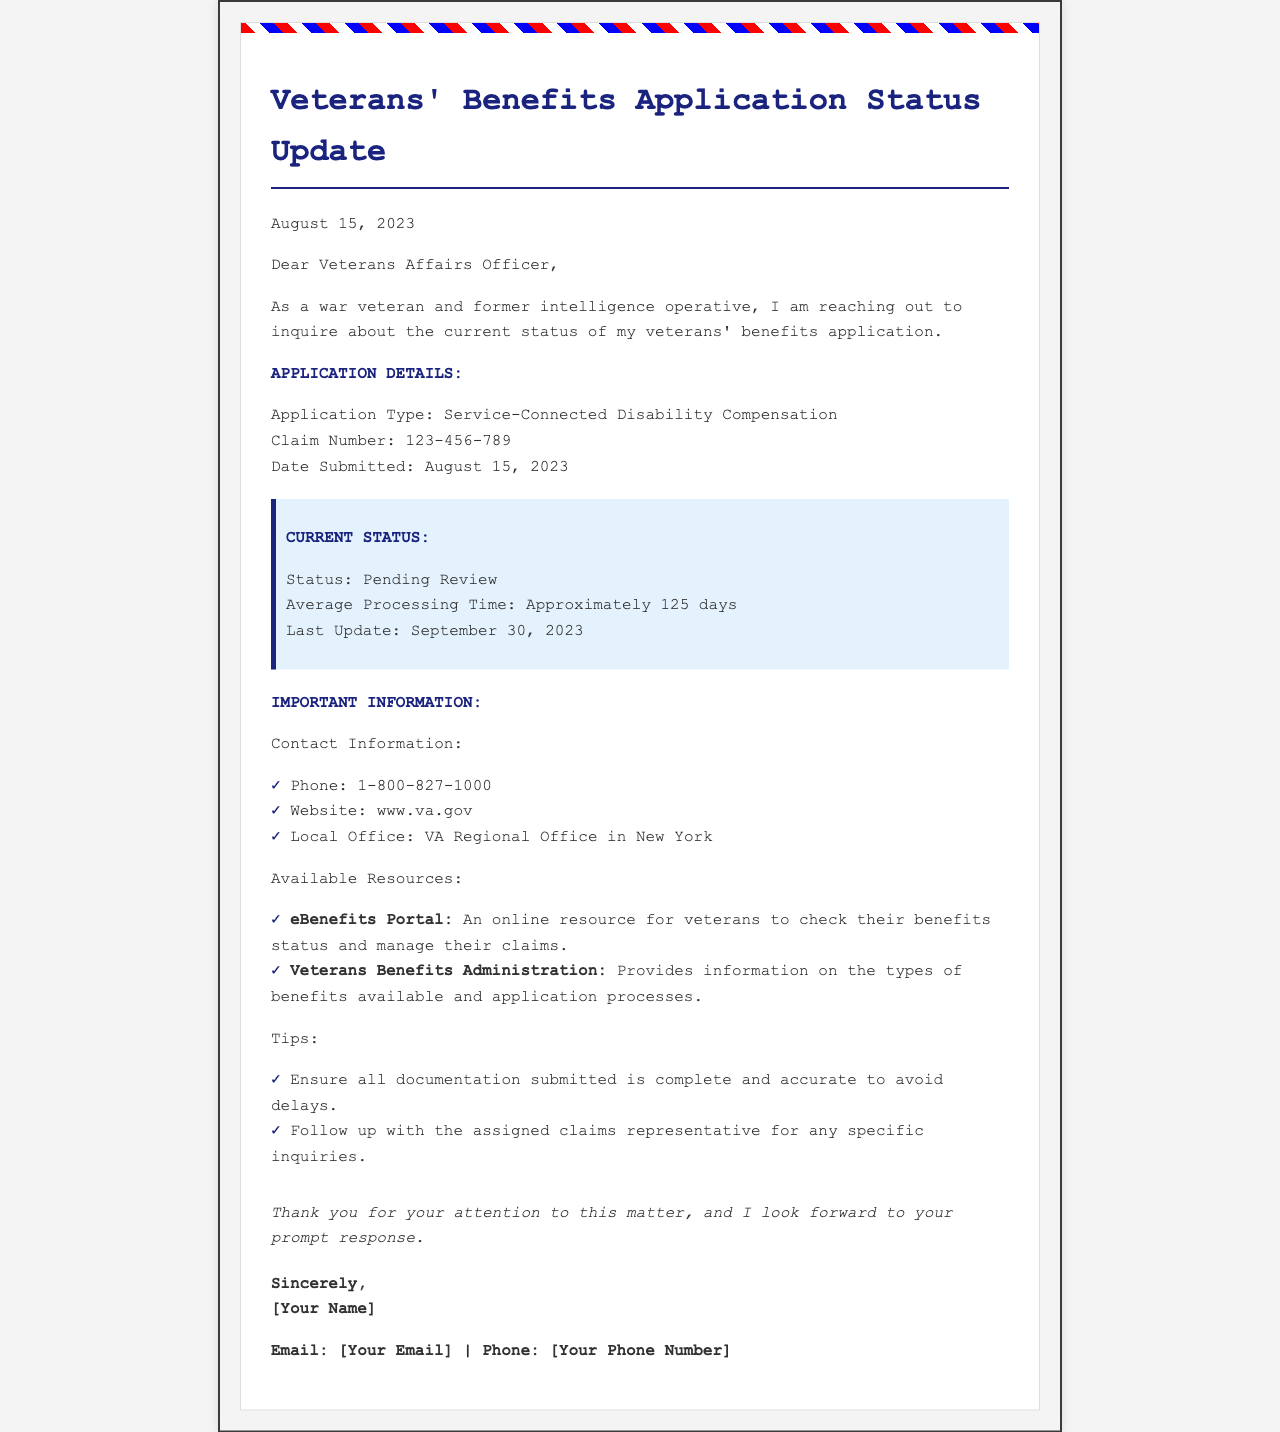What is the title of the document? The title is stated at the top of the document, indicating the purpose of the letter regarding application status.
Answer: Veterans' Benefits Application Status Update What is the application type mentioned? The application type is specifically detailed in the document under the Application Details section.
Answer: Service-Connected Disability Compensation When was the application submitted? The submission date is provided in the Application Details section of the document.
Answer: August 15, 2023 What is the current status of the application? The current status is specified in the Current Status section of the document.
Answer: Pending Review What is the average processing time? The average processing time is given in the Current Status section of the document as a specific duration.
Answer: Approximately 125 days When was the last update provided? The document mentions the last update date in the Current Status section.
Answer: September 30, 2023 What is the contact phone number provided? The contact phone number is listed in the Important Information section of the document.
Answer: 1-800-827-1000 What online resource is available for checking benefits status? An online resource is mentioned that can help veterans check their benefits status in the Resources section.
Answer: eBenefits Portal What tips are provided to avoid delays in the application process? The document suggests specific actions in the Tips section to avoid delays.
Answer: Ensure all documentation submitted is complete and accurate to avoid delays 